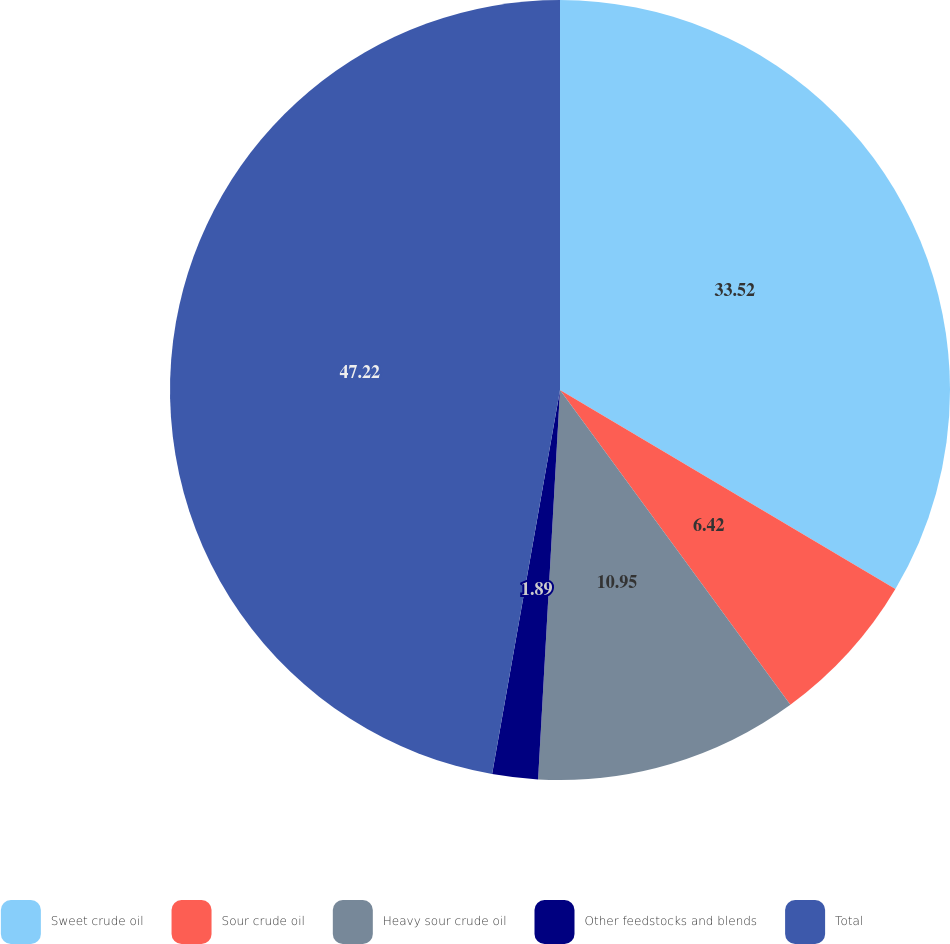Convert chart to OTSL. <chart><loc_0><loc_0><loc_500><loc_500><pie_chart><fcel>Sweet crude oil<fcel>Sour crude oil<fcel>Heavy sour crude oil<fcel>Other feedstocks and blends<fcel>Total<nl><fcel>33.52%<fcel>6.42%<fcel>10.95%<fcel>1.89%<fcel>47.21%<nl></chart> 